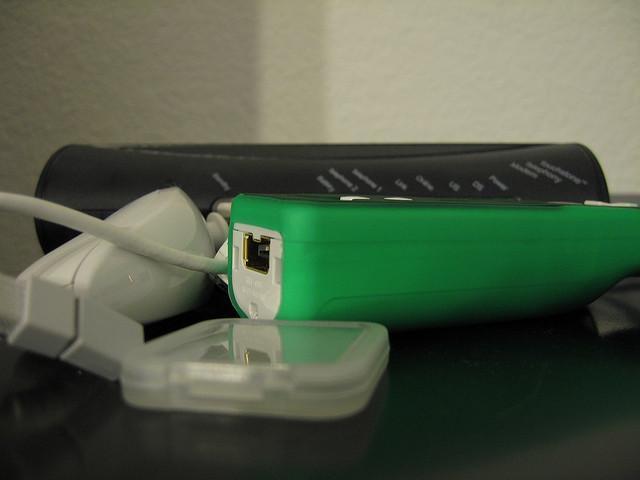How many remotes are in the picture?
Give a very brief answer. 3. How many airplanes are there flying in the photo?
Give a very brief answer. 0. 